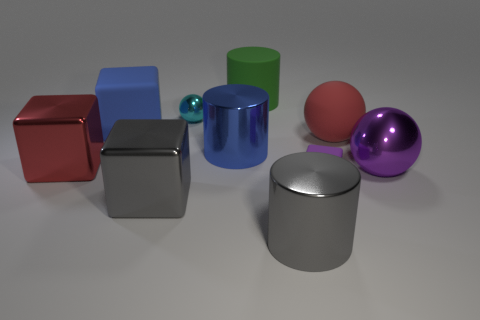What color is the tiny metal ball?
Your response must be concise. Cyan. Are there any other things that are the same color as the matte cylinder?
Offer a terse response. No. What is the shape of the large matte object that is both left of the small purple thing and in front of the large green matte thing?
Your answer should be very brief. Cube. Are there an equal number of big blue objects that are to the right of the purple metal thing and metallic things that are in front of the big red matte thing?
Keep it short and to the point. No. How many balls are either tiny purple rubber objects or green things?
Provide a short and direct response. 0. How many tiny spheres are made of the same material as the gray cylinder?
Keep it short and to the point. 1. There is a thing that is the same color as the big shiny ball; what is its shape?
Keep it short and to the point. Cube. What material is the thing that is both right of the gray cylinder and on the left side of the red rubber thing?
Offer a terse response. Rubber. The gray shiny thing that is on the left side of the big blue cylinder has what shape?
Provide a short and direct response. Cube. What is the shape of the large red object in front of the blue object that is in front of the large red rubber object?
Give a very brief answer. Cube. 